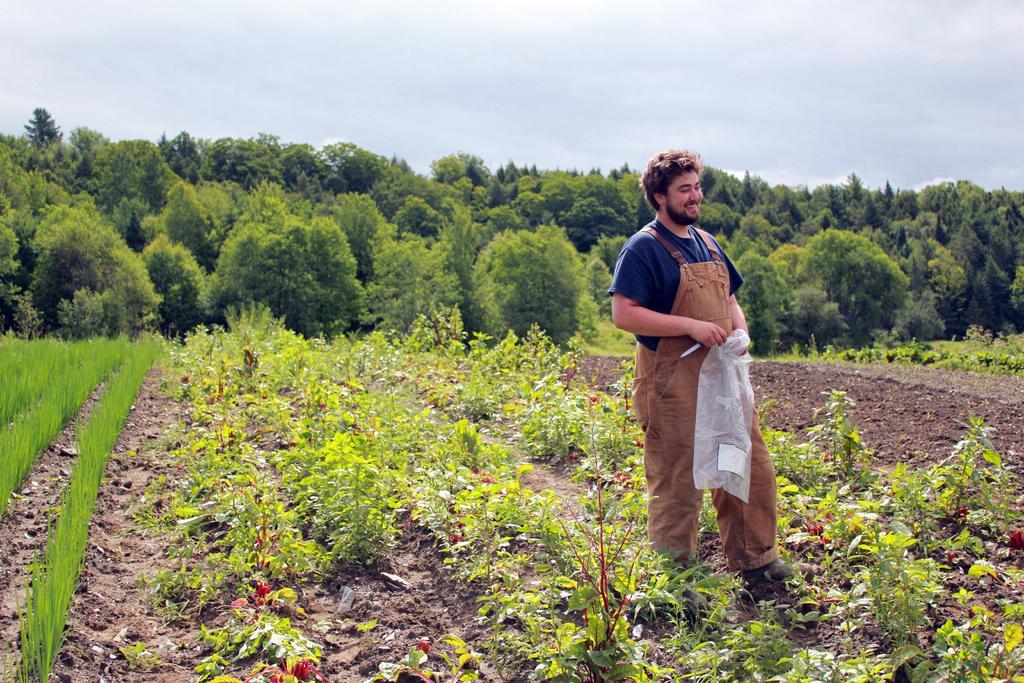Can you describe this image briefly? In this picture I can see the soil on which there are number of plants and I see a man who is standing and holding a white color thing in his hands and I see that he is smiling. In the background I see number of trees and the sky. 